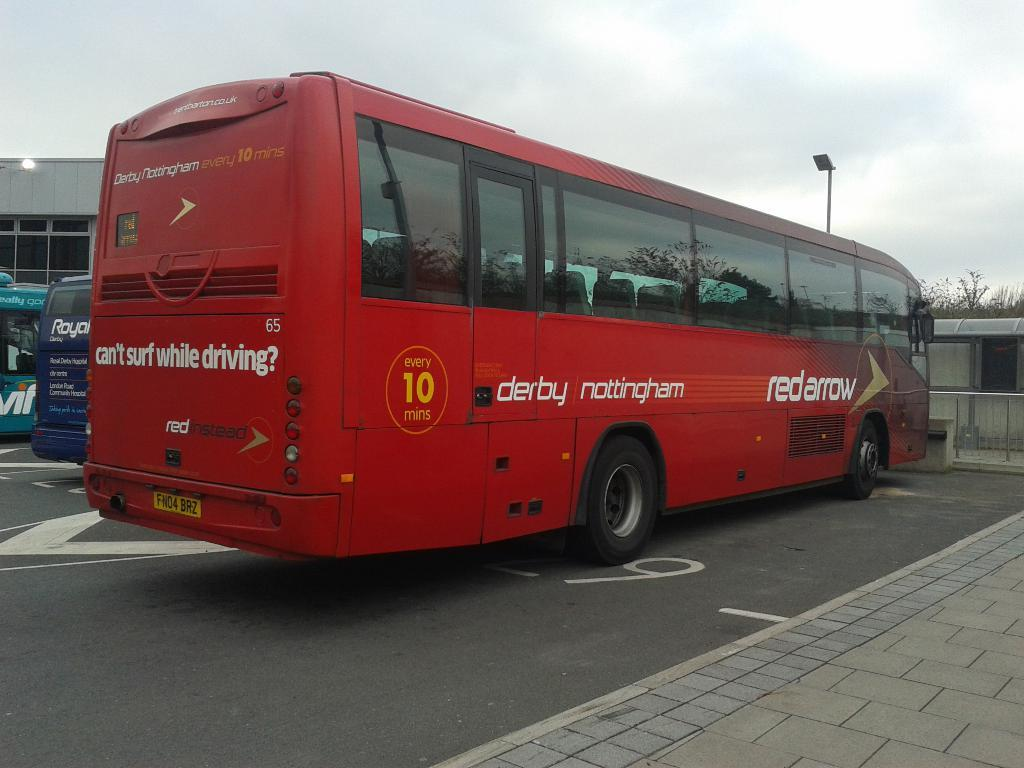What type of vehicles are in the image? There are buses in the image. What colors are the buses? The buses are in red, blue, and green colors. What else can be seen in the image besides the buses? There are buildings, windows, trees, and a railing in the image. What is the color of the sky in the image? The sky is blue and white in color. What type of treatment is being administered to the tree in the image? There is no treatment being administered to a tree in the image; there are only buses, buildings, windows, trees, and a railing present. How many branches can be seen on the bubble in the image? There is no bubble present in the image, so it is not possible to determine the number of branches on a bubble. 